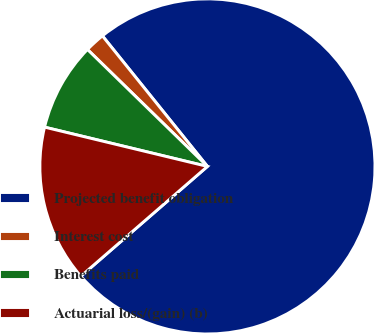Convert chart to OTSL. <chart><loc_0><loc_0><loc_500><loc_500><pie_chart><fcel>Projected benefit obligation<fcel>Interest cost<fcel>Benefits paid<fcel>Actuarial loss/(gain) (b)<nl><fcel>74.41%<fcel>1.92%<fcel>8.53%<fcel>15.14%<nl></chart> 